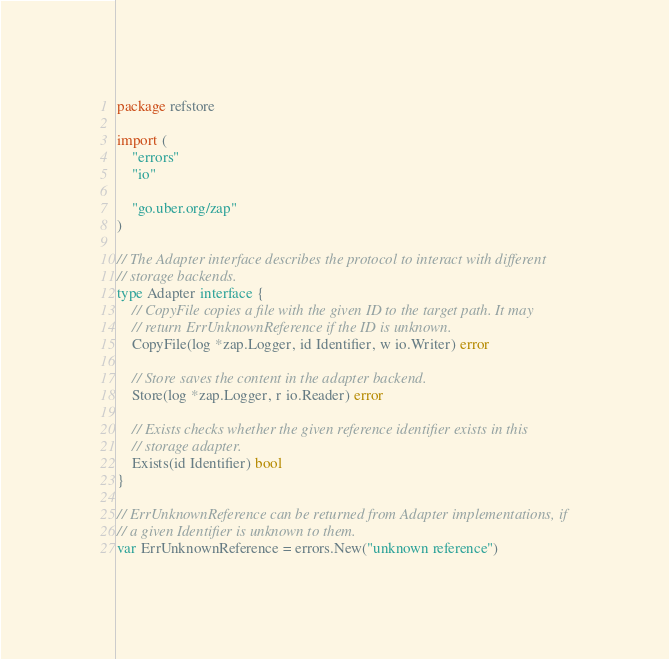<code> <loc_0><loc_0><loc_500><loc_500><_Go_>package refstore

import (
	"errors"
	"io"

	"go.uber.org/zap"
)

// The Adapter interface describes the protocol to interact with different
// storage backends.
type Adapter interface {
	// CopyFile copies a file with the given ID to the target path. It may
	// return ErrUnknownReference if the ID is unknown.
	CopyFile(log *zap.Logger, id Identifier, w io.Writer) error

	// Store saves the content in the adapter backend.
	Store(log *zap.Logger, r io.Reader) error

	// Exists checks whether the given reference identifier exists in this
	// storage adapter.
	Exists(id Identifier) bool
}

// ErrUnknownReference can be returned from Adapter implementations, if
// a given Identifier is unknown to them.
var ErrUnknownReference = errors.New("unknown reference")
</code> 